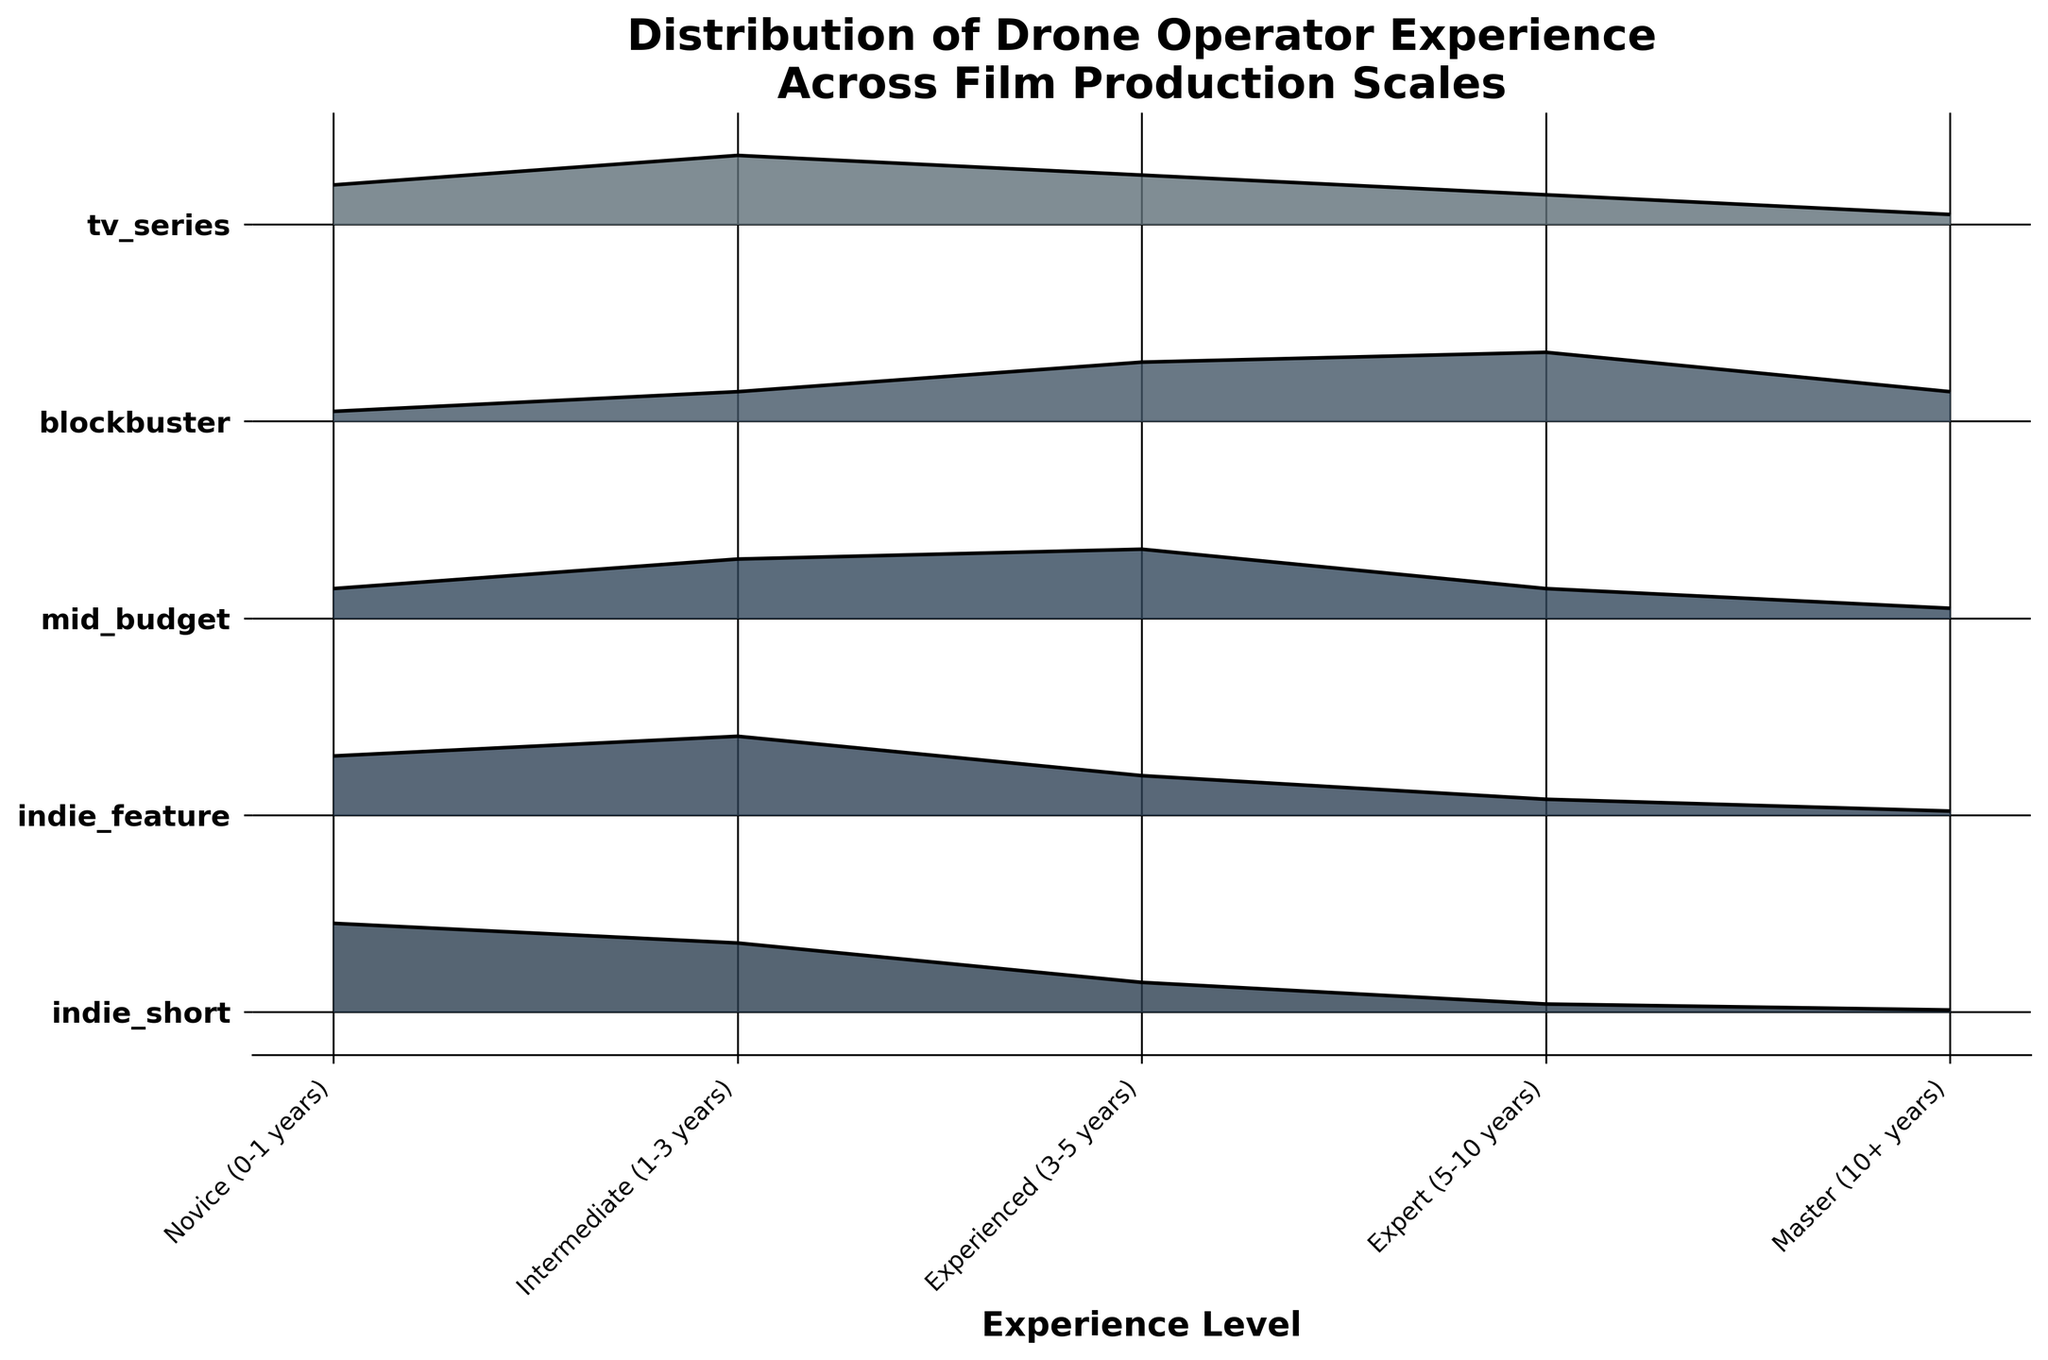What is the title of the figure? The title is usually placed at the top of the figure. It provides the main context or subject of the plot.
Answer: Distribution of Drone Operator Experience Across Film Production Scales Which film production scale has the highest proportion of novice drone operators? Look at the proportions of novice drone operators (0-1 years) depicted in the plot for each category of film production.
Answer: Indie Short How does the proportion of expert drone operators (5-10 years) in indie features compare to blockbusters? Look at the heights of the ridgeline for expert drone operators in both indie features and blockbusters. The proportion appears lower in indie features and higher in blockbusters.
Answer: Higher in blockbusters Between mid-budget and TV series productions, which one employs more master drone operators (10+ years)? Compare the heights of the ridgelines for master drone operators (10+ years) in mid-budget and TV series categories.
Answer: Mid-budget Which experience level is most common in TV series productions? Look at the heights of the ridgelines within the TV series category. The highest point represents the most common experience level.
Answer: Intermediate (1-3 years) Can you determine which production scale has the most even distribution across all experience levels? An even distribution implies that ridgelines vary the least from one another in height across experience levels for a given category.
Answer: Mid-budget Which experience level is least represented in indie short productions? Identify the experience level with the smallest proportion within the indie short category by looking at the heights of the ridgelines.
Answer: Master (10+ years) How does the distribution of experienced drone operators (3-5 years) vary between indie features and blockbusters? Compare the ridgeline heights for experienced drone operators in both indie features and blockbusters.
Answer: Higher in blockbusters What's the sum of the proportions of master drone operators across all production scales? Add the proportion values of master drone operators for all categories. 0.01 (Indie Short) + 0.02 (Indie Feature) + 0.05 (Mid-budget) + 0.15 (Blockbuster) + 0.05 (TV Series) = 0.28
Answer: 0.28 